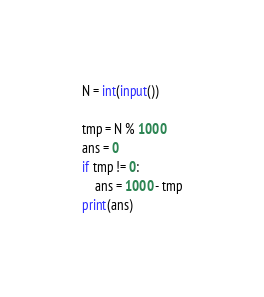Convert code to text. <code><loc_0><loc_0><loc_500><loc_500><_Python_>N = int(input())

tmp = N % 1000
ans = 0
if tmp != 0:
    ans = 1000 - tmp
print(ans)</code> 